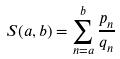<formula> <loc_0><loc_0><loc_500><loc_500>S ( a , b ) = \sum _ { n = a } ^ { b } \frac { p _ { n } } { q _ { n } }</formula> 